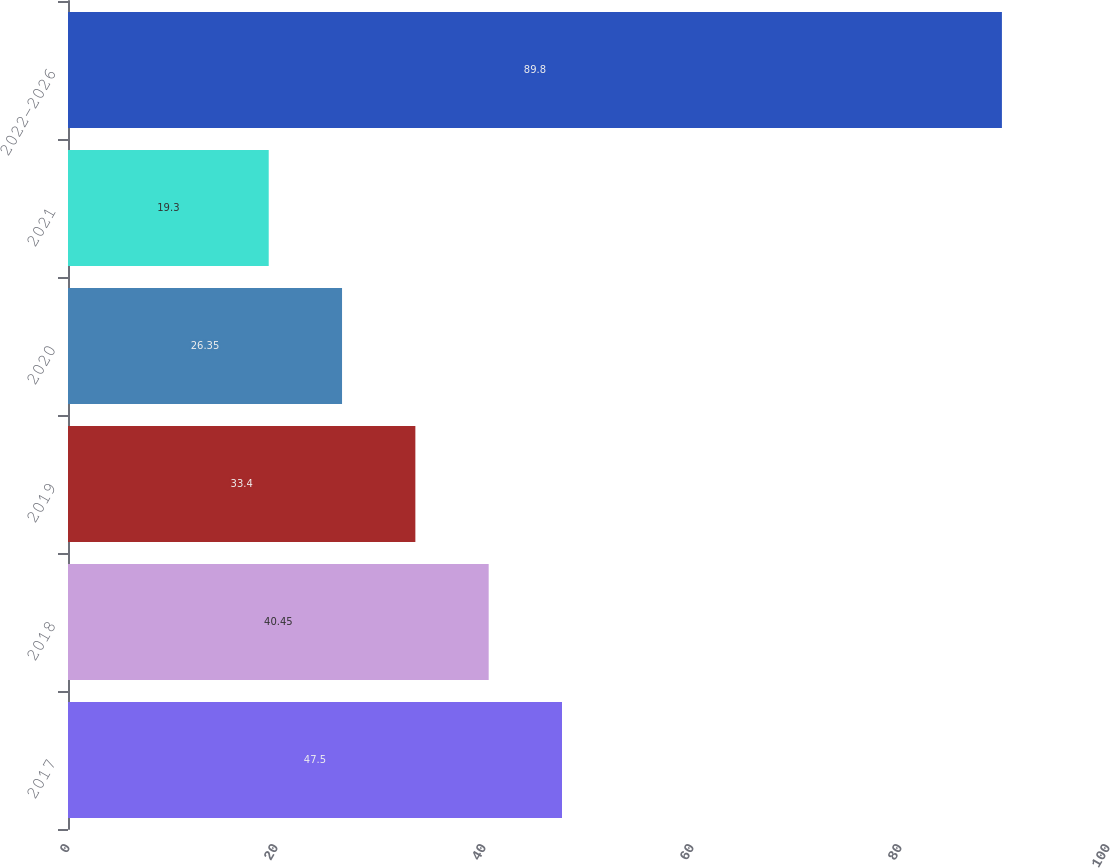Convert chart. <chart><loc_0><loc_0><loc_500><loc_500><bar_chart><fcel>2017<fcel>2018<fcel>2019<fcel>2020<fcel>2021<fcel>2022-2026<nl><fcel>47.5<fcel>40.45<fcel>33.4<fcel>26.35<fcel>19.3<fcel>89.8<nl></chart> 